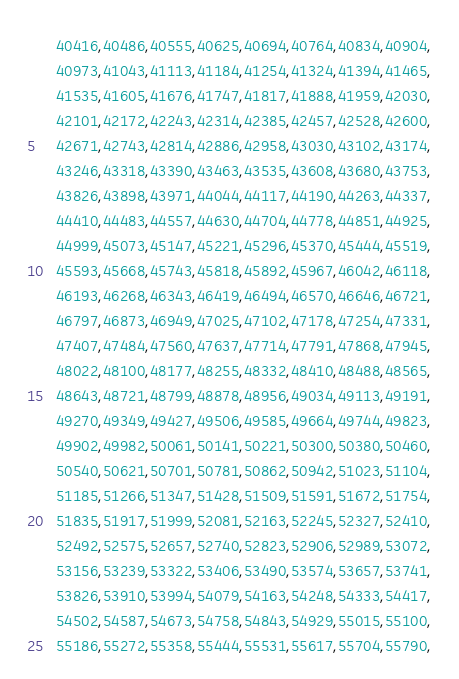<code> <loc_0><loc_0><loc_500><loc_500><_C_>    40416,40486,40555,40625,40694,40764,40834,40904,
    40973,41043,41113,41184,41254,41324,41394,41465,
    41535,41605,41676,41747,41817,41888,41959,42030,
    42101,42172,42243,42314,42385,42457,42528,42600,
    42671,42743,42814,42886,42958,43030,43102,43174,
    43246,43318,43390,43463,43535,43608,43680,43753,
    43826,43898,43971,44044,44117,44190,44263,44337,
    44410,44483,44557,44630,44704,44778,44851,44925,
    44999,45073,45147,45221,45296,45370,45444,45519,
    45593,45668,45743,45818,45892,45967,46042,46118,
    46193,46268,46343,46419,46494,46570,46646,46721,
    46797,46873,46949,47025,47102,47178,47254,47331,
    47407,47484,47560,47637,47714,47791,47868,47945,
    48022,48100,48177,48255,48332,48410,48488,48565,
    48643,48721,48799,48878,48956,49034,49113,49191,
    49270,49349,49427,49506,49585,49664,49744,49823,
    49902,49982,50061,50141,50221,50300,50380,50460,
    50540,50621,50701,50781,50862,50942,51023,51104,
    51185,51266,51347,51428,51509,51591,51672,51754,
    51835,51917,51999,52081,52163,52245,52327,52410,
    52492,52575,52657,52740,52823,52906,52989,53072,
    53156,53239,53322,53406,53490,53574,53657,53741,
    53826,53910,53994,54079,54163,54248,54333,54417,
    54502,54587,54673,54758,54843,54929,55015,55100,
    55186,55272,55358,55444,55531,55617,55704,55790,</code> 